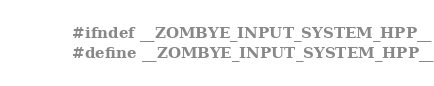Convert code to text. <code><loc_0><loc_0><loc_500><loc_500><_C++_>#ifndef __ZOMBYE_INPUT_SYSTEM_HPP__
#define __ZOMBYE_INPUT_SYSTEM_HPP__
</code> 